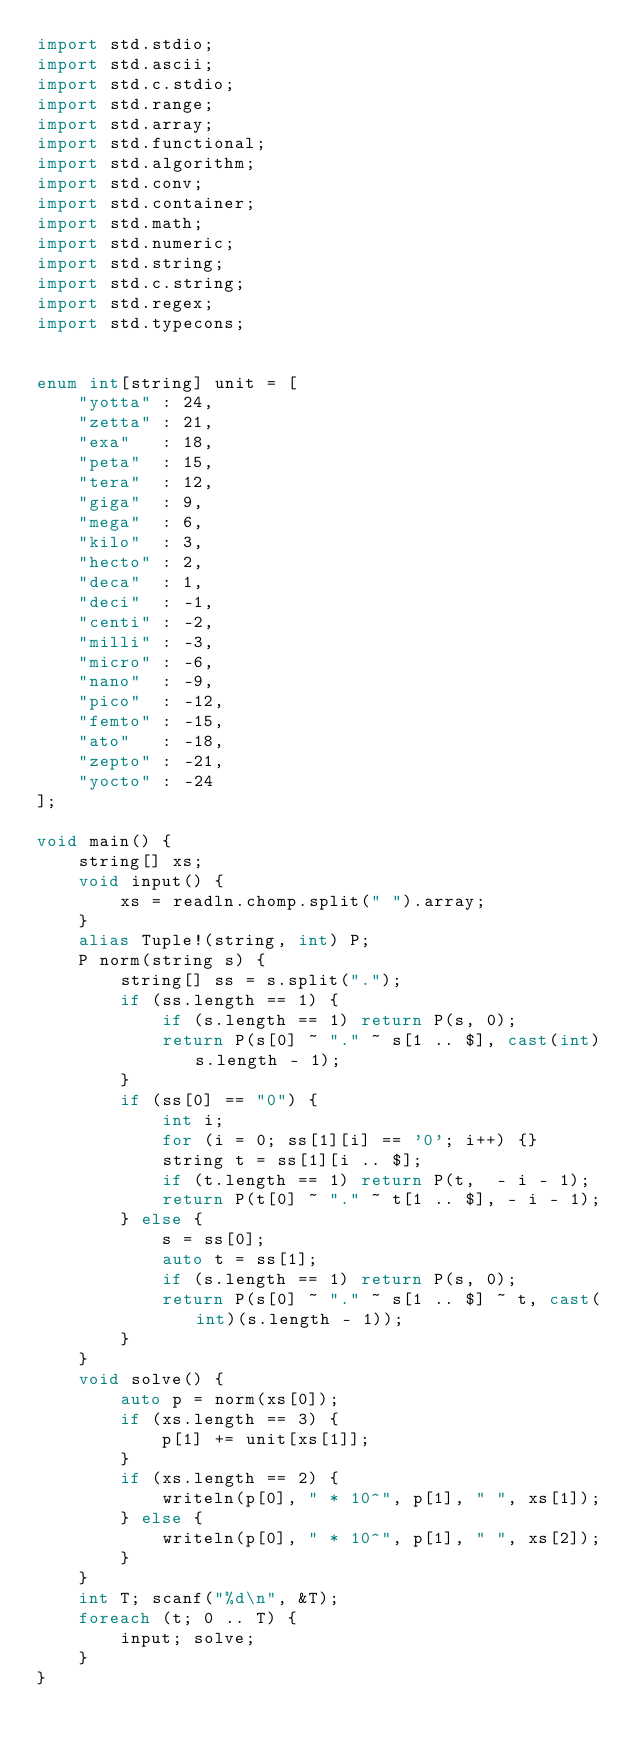Convert code to text. <code><loc_0><loc_0><loc_500><loc_500><_D_>import std.stdio;
import std.ascii;
import std.c.stdio;
import std.range;
import std.array;
import std.functional;
import std.algorithm;
import std.conv;
import std.container;
import std.math;
import std.numeric;
import std.string;
import std.c.string;
import std.regex;
import std.typecons;


enum int[string] unit = [
    "yotta" : 24,
    "zetta" : 21,
    "exa"   : 18,
    "peta"  : 15,
    "tera"  : 12,
    "giga"  : 9,
    "mega"  : 6,
    "kilo"  : 3,
    "hecto" : 2,
    "deca"  : 1,
    "deci"  : -1,
    "centi" : -2,
    "milli" : -3,
    "micro" : -6,
    "nano"  : -9,
    "pico"  : -12,
    "femto" : -15,
    "ato"   : -18,
    "zepto" : -21,
    "yocto" : -24
];

void main() {
    string[] xs;
    void input() {
        xs = readln.chomp.split(" ").array;
    }
    alias Tuple!(string, int) P;
    P norm(string s) {
        string[] ss = s.split(".");
        if (ss.length == 1) {
            if (s.length == 1) return P(s, 0);
            return P(s[0] ~ "." ~ s[1 .. $], cast(int)s.length - 1);
        }
        if (ss[0] == "0") {
            int i;
            for (i = 0; ss[1][i] == '0'; i++) {}
            string t = ss[1][i .. $];
            if (t.length == 1) return P(t,  - i - 1);
            return P(t[0] ~ "." ~ t[1 .. $], - i - 1);
        } else {
            s = ss[0];
            auto t = ss[1];
            if (s.length == 1) return P(s, 0);
            return P(s[0] ~ "." ~ s[1 .. $] ~ t, cast(int)(s.length - 1));
        }
    }
    void solve() {
        auto p = norm(xs[0]);
        if (xs.length == 3) {
            p[1] += unit[xs[1]];
        }
        if (xs.length == 2) {
            writeln(p[0], " * 10^", p[1], " ", xs[1]);
        } else {
            writeln(p[0], " * 10^", p[1], " ", xs[2]);
        }
    }
    int T; scanf("%d\n", &T);
    foreach (t; 0 .. T) {
        input; solve;
    }
}</code> 